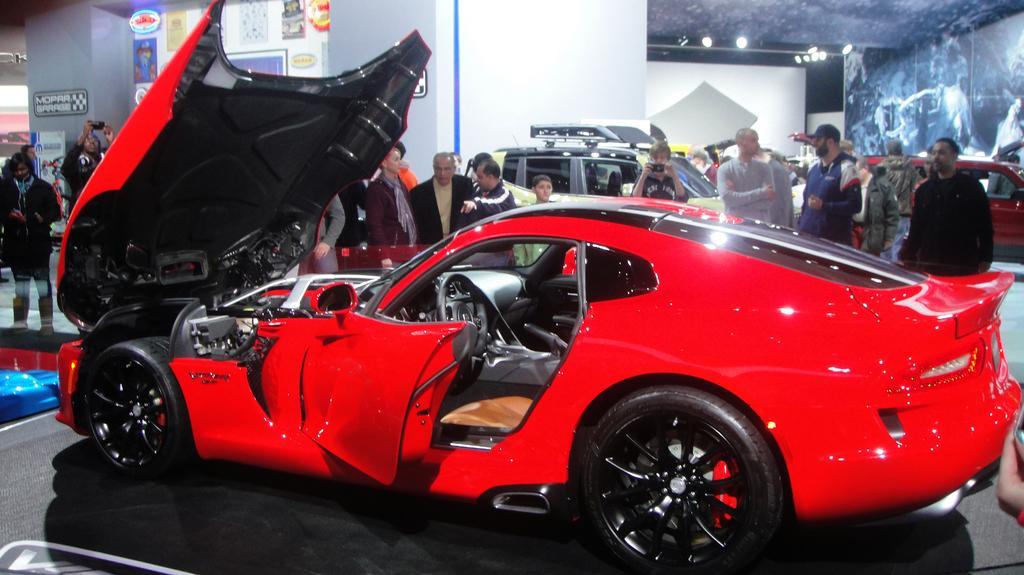Could you give a brief overview of what you see in this image? In this picture I can see few cars and few people standing. I can see a car bonnet is opened and few boards with some text and I can see lights to the ceiling. 